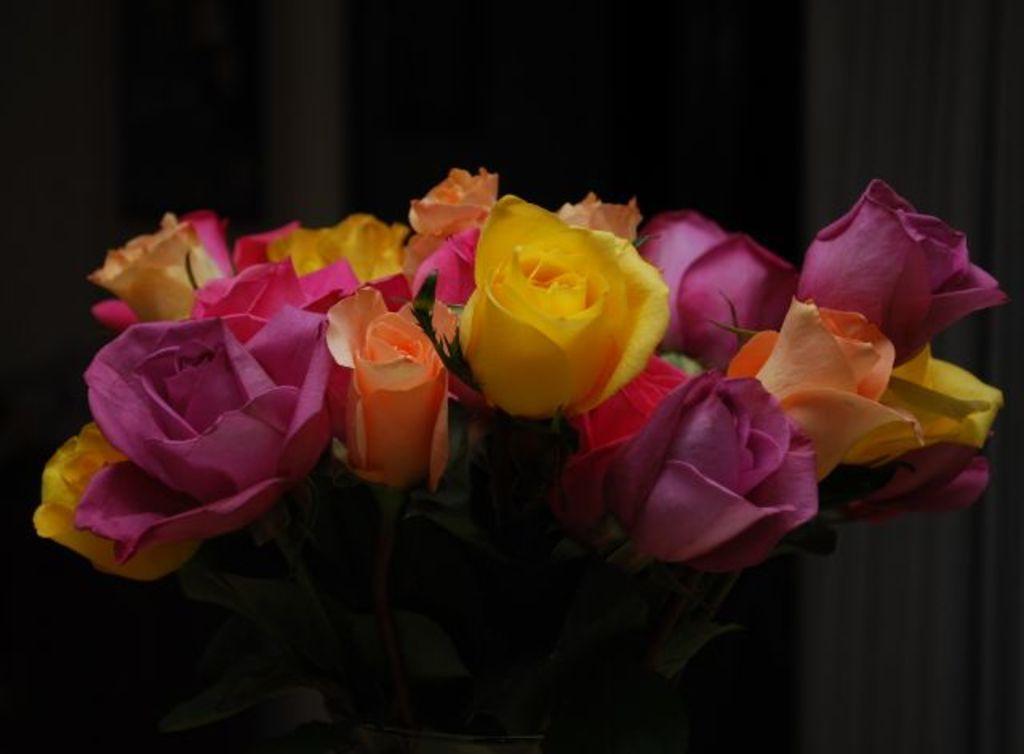How would you summarize this image in a sentence or two? In the image we can see a flower bookey, in it there are many flowers of different colors and the background is dark. 